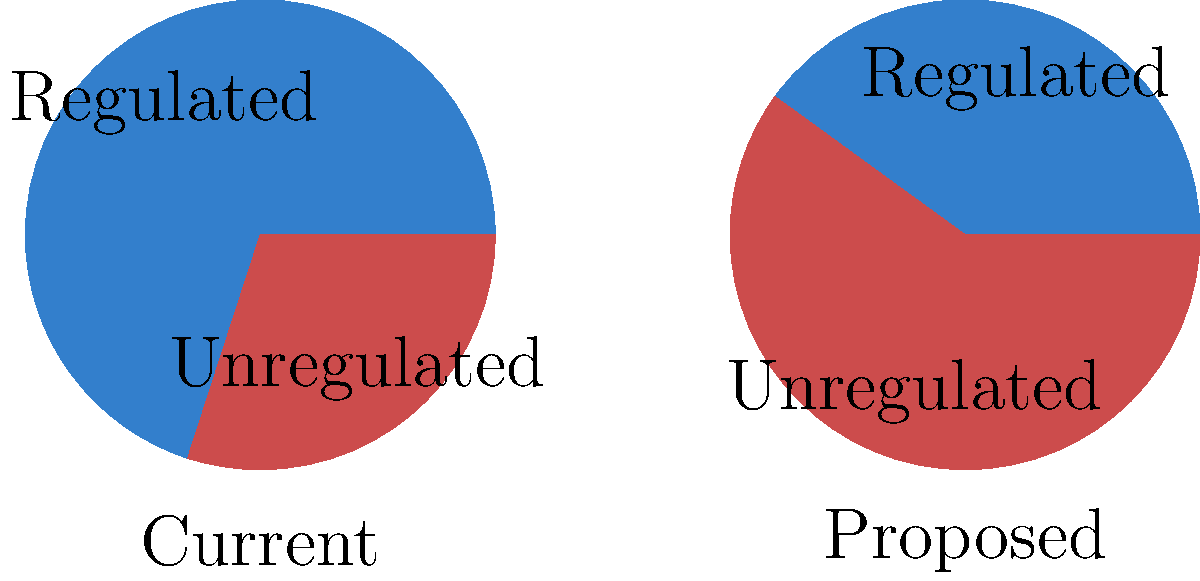As a lawmaker advocating for increased media regulation to protect national security, you are presented with two pie charts comparing the current and proposed distribution of regulated vs unregulated media content. The left chart shows the current situation, while the right chart represents the proposed scenario after implementing new regulations. By what percentage would the share of regulated media content decrease under the proposed scenario? To solve this problem, we need to follow these steps:

1. Identify the current percentage of regulated media content:
   In the left pie chart (current situation), regulated content is 70%.

2. Identify the proposed percentage of regulated media content:
   In the right pie chart (proposed scenario), regulated content is 40%.

3. Calculate the decrease in regulated content:
   Decrease = Current percentage - Proposed percentage
   Decrease = 70% - 40% = 30%

4. Calculate the percentage decrease relative to the original value:
   Percentage decrease = (Decrease / Original value) × 100%
   Percentage decrease = (30% / 70%) × 100% = 42.86%

Therefore, the share of regulated media content would decrease by approximately 42.86% under the proposed scenario.
Answer: 42.86% 